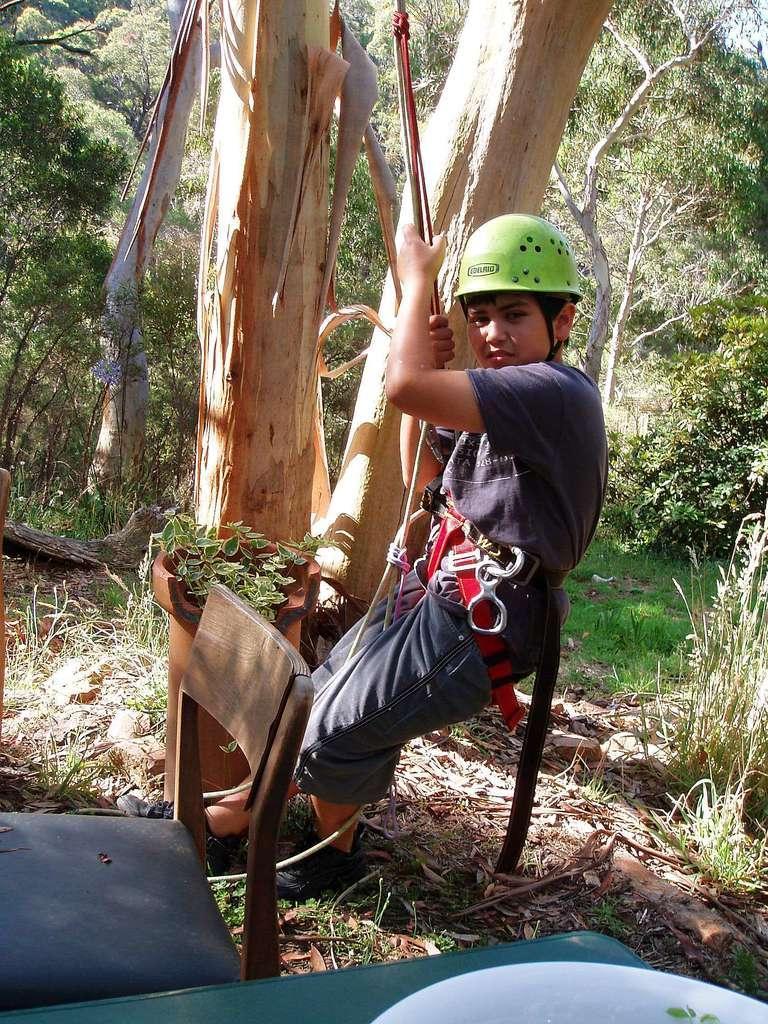Describe this image in one or two sentences. In this image there is a person wearing a grey dress and green helmet, holding a rope. In the background there is are group of trees and plants. In the bottom there is a plate and a chair. 